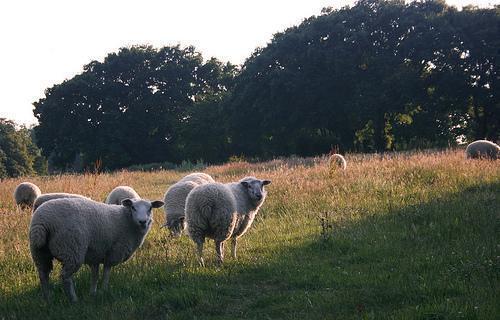How many sheep in left corner?
Give a very brief answer. 5. 